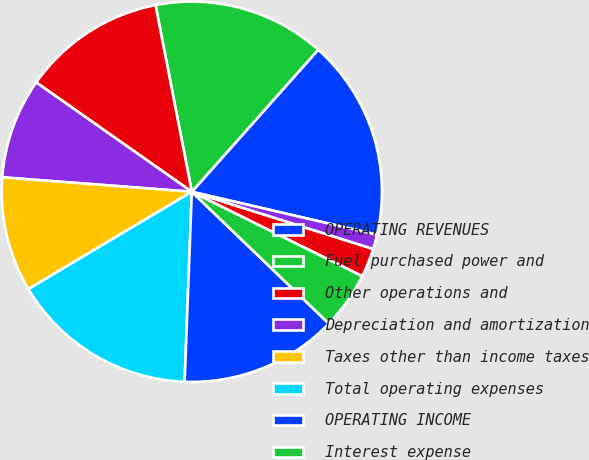Convert chart. <chart><loc_0><loc_0><loc_500><loc_500><pie_chart><fcel>OPERATING REVENUES<fcel>Fuel purchased power and<fcel>Other operations and<fcel>Depreciation and amortization<fcel>Taxes other than income taxes<fcel>Total operating expenses<fcel>OPERATING INCOME<fcel>Interest expense<fcel>Allowance for equity funds<fcel>Interest income<nl><fcel>17.06%<fcel>14.63%<fcel>12.19%<fcel>8.54%<fcel>9.76%<fcel>15.85%<fcel>13.41%<fcel>4.88%<fcel>2.45%<fcel>1.23%<nl></chart> 